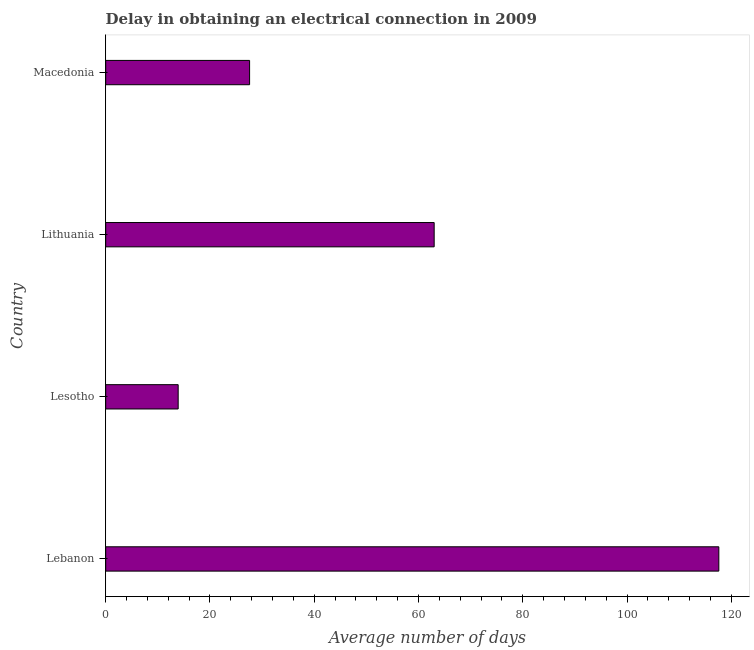What is the title of the graph?
Offer a very short reply. Delay in obtaining an electrical connection in 2009. What is the label or title of the X-axis?
Make the answer very short. Average number of days. Across all countries, what is the maximum dalay in electrical connection?
Your response must be concise. 117.6. Across all countries, what is the minimum dalay in electrical connection?
Your answer should be compact. 13.9. In which country was the dalay in electrical connection maximum?
Give a very brief answer. Lebanon. In which country was the dalay in electrical connection minimum?
Your answer should be compact. Lesotho. What is the sum of the dalay in electrical connection?
Provide a short and direct response. 222.1. What is the difference between the dalay in electrical connection in Lebanon and Macedonia?
Ensure brevity in your answer.  90. What is the average dalay in electrical connection per country?
Your answer should be very brief. 55.52. What is the median dalay in electrical connection?
Offer a terse response. 45.3. In how many countries, is the dalay in electrical connection greater than 44 days?
Provide a succinct answer. 2. What is the ratio of the dalay in electrical connection in Lesotho to that in Macedonia?
Offer a terse response. 0.5. Is the dalay in electrical connection in Lesotho less than that in Lithuania?
Your answer should be compact. Yes. Is the difference between the dalay in electrical connection in Lesotho and Lithuania greater than the difference between any two countries?
Make the answer very short. No. What is the difference between the highest and the second highest dalay in electrical connection?
Offer a very short reply. 54.6. What is the difference between the highest and the lowest dalay in electrical connection?
Provide a succinct answer. 103.7. In how many countries, is the dalay in electrical connection greater than the average dalay in electrical connection taken over all countries?
Give a very brief answer. 2. How many bars are there?
Give a very brief answer. 4. How many countries are there in the graph?
Ensure brevity in your answer.  4. What is the difference between two consecutive major ticks on the X-axis?
Keep it short and to the point. 20. What is the Average number of days of Lebanon?
Your answer should be compact. 117.6. What is the Average number of days in Lesotho?
Ensure brevity in your answer.  13.9. What is the Average number of days of Macedonia?
Keep it short and to the point. 27.6. What is the difference between the Average number of days in Lebanon and Lesotho?
Provide a short and direct response. 103.7. What is the difference between the Average number of days in Lebanon and Lithuania?
Provide a succinct answer. 54.6. What is the difference between the Average number of days in Lesotho and Lithuania?
Make the answer very short. -49.1. What is the difference between the Average number of days in Lesotho and Macedonia?
Ensure brevity in your answer.  -13.7. What is the difference between the Average number of days in Lithuania and Macedonia?
Offer a very short reply. 35.4. What is the ratio of the Average number of days in Lebanon to that in Lesotho?
Offer a very short reply. 8.46. What is the ratio of the Average number of days in Lebanon to that in Lithuania?
Offer a very short reply. 1.87. What is the ratio of the Average number of days in Lebanon to that in Macedonia?
Your response must be concise. 4.26. What is the ratio of the Average number of days in Lesotho to that in Lithuania?
Your answer should be compact. 0.22. What is the ratio of the Average number of days in Lesotho to that in Macedonia?
Offer a very short reply. 0.5. What is the ratio of the Average number of days in Lithuania to that in Macedonia?
Keep it short and to the point. 2.28. 